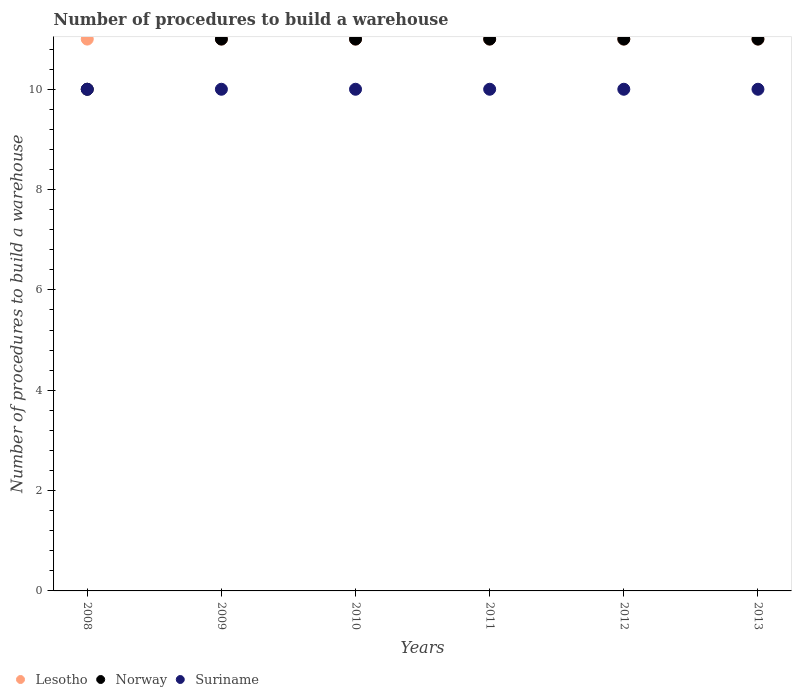How many different coloured dotlines are there?
Offer a terse response. 3. What is the number of procedures to build a warehouse in in Lesotho in 2008?
Keep it short and to the point. 11. Across all years, what is the maximum number of procedures to build a warehouse in in Norway?
Your answer should be compact. 11. Across all years, what is the minimum number of procedures to build a warehouse in in Lesotho?
Offer a very short reply. 11. In which year was the number of procedures to build a warehouse in in Suriname minimum?
Provide a short and direct response. 2008. What is the total number of procedures to build a warehouse in in Suriname in the graph?
Offer a very short reply. 60. What is the difference between the number of procedures to build a warehouse in in Lesotho in 2008 and that in 2009?
Offer a terse response. 0. What is the difference between the number of procedures to build a warehouse in in Suriname in 2011 and the number of procedures to build a warehouse in in Norway in 2008?
Your answer should be compact. 0. What is the average number of procedures to build a warehouse in in Lesotho per year?
Your answer should be compact. 11. In the year 2013, what is the difference between the number of procedures to build a warehouse in in Suriname and number of procedures to build a warehouse in in Norway?
Your answer should be compact. -1. In how many years, is the number of procedures to build a warehouse in in Norway greater than 5.6?
Your answer should be compact. 6. Is the difference between the number of procedures to build a warehouse in in Suriname in 2012 and 2013 greater than the difference between the number of procedures to build a warehouse in in Norway in 2012 and 2013?
Make the answer very short. No. What is the difference between the highest and the lowest number of procedures to build a warehouse in in Norway?
Your answer should be compact. 1. Is the number of procedures to build a warehouse in in Lesotho strictly greater than the number of procedures to build a warehouse in in Norway over the years?
Your response must be concise. No. Is the number of procedures to build a warehouse in in Lesotho strictly less than the number of procedures to build a warehouse in in Norway over the years?
Offer a terse response. No. How many years are there in the graph?
Your response must be concise. 6. What is the difference between two consecutive major ticks on the Y-axis?
Your answer should be very brief. 2. Does the graph contain any zero values?
Provide a short and direct response. No. Where does the legend appear in the graph?
Provide a succinct answer. Bottom left. How many legend labels are there?
Offer a terse response. 3. What is the title of the graph?
Provide a short and direct response. Number of procedures to build a warehouse. Does "Honduras" appear as one of the legend labels in the graph?
Offer a terse response. No. What is the label or title of the X-axis?
Keep it short and to the point. Years. What is the label or title of the Y-axis?
Ensure brevity in your answer.  Number of procedures to build a warehouse. What is the Number of procedures to build a warehouse of Lesotho in 2008?
Ensure brevity in your answer.  11. What is the Number of procedures to build a warehouse of Lesotho in 2009?
Make the answer very short. 11. What is the Number of procedures to build a warehouse in Norway in 2009?
Give a very brief answer. 11. What is the Number of procedures to build a warehouse of Lesotho in 2010?
Your answer should be very brief. 11. What is the Number of procedures to build a warehouse of Lesotho in 2011?
Offer a very short reply. 11. What is the Number of procedures to build a warehouse in Lesotho in 2012?
Offer a terse response. 11. What is the Number of procedures to build a warehouse in Suriname in 2012?
Keep it short and to the point. 10. What is the Number of procedures to build a warehouse of Norway in 2013?
Provide a succinct answer. 11. What is the total Number of procedures to build a warehouse of Norway in the graph?
Make the answer very short. 65. What is the difference between the Number of procedures to build a warehouse in Norway in 2008 and that in 2009?
Provide a succinct answer. -1. What is the difference between the Number of procedures to build a warehouse in Norway in 2008 and that in 2010?
Offer a very short reply. -1. What is the difference between the Number of procedures to build a warehouse of Suriname in 2008 and that in 2010?
Give a very brief answer. 0. What is the difference between the Number of procedures to build a warehouse in Norway in 2008 and that in 2011?
Your answer should be very brief. -1. What is the difference between the Number of procedures to build a warehouse of Lesotho in 2008 and that in 2012?
Ensure brevity in your answer.  0. What is the difference between the Number of procedures to build a warehouse in Norway in 2008 and that in 2012?
Make the answer very short. -1. What is the difference between the Number of procedures to build a warehouse of Suriname in 2008 and that in 2012?
Your answer should be very brief. 0. What is the difference between the Number of procedures to build a warehouse of Suriname in 2008 and that in 2013?
Provide a short and direct response. 0. What is the difference between the Number of procedures to build a warehouse in Lesotho in 2009 and that in 2010?
Your answer should be compact. 0. What is the difference between the Number of procedures to build a warehouse of Suriname in 2009 and that in 2010?
Keep it short and to the point. 0. What is the difference between the Number of procedures to build a warehouse in Norway in 2009 and that in 2011?
Your response must be concise. 0. What is the difference between the Number of procedures to build a warehouse in Suriname in 2009 and that in 2011?
Offer a terse response. 0. What is the difference between the Number of procedures to build a warehouse in Lesotho in 2009 and that in 2012?
Provide a succinct answer. 0. What is the difference between the Number of procedures to build a warehouse in Lesotho in 2009 and that in 2013?
Your answer should be compact. 0. What is the difference between the Number of procedures to build a warehouse in Norway in 2009 and that in 2013?
Offer a terse response. 0. What is the difference between the Number of procedures to build a warehouse of Suriname in 2009 and that in 2013?
Provide a succinct answer. 0. What is the difference between the Number of procedures to build a warehouse of Lesotho in 2010 and that in 2011?
Offer a very short reply. 0. What is the difference between the Number of procedures to build a warehouse of Norway in 2010 and that in 2011?
Your answer should be very brief. 0. What is the difference between the Number of procedures to build a warehouse in Suriname in 2010 and that in 2011?
Your answer should be compact. 0. What is the difference between the Number of procedures to build a warehouse of Lesotho in 2010 and that in 2012?
Offer a terse response. 0. What is the difference between the Number of procedures to build a warehouse of Suriname in 2010 and that in 2012?
Keep it short and to the point. 0. What is the difference between the Number of procedures to build a warehouse of Lesotho in 2010 and that in 2013?
Your answer should be compact. 0. What is the difference between the Number of procedures to build a warehouse of Lesotho in 2011 and that in 2012?
Ensure brevity in your answer.  0. What is the difference between the Number of procedures to build a warehouse in Suriname in 2011 and that in 2012?
Your response must be concise. 0. What is the difference between the Number of procedures to build a warehouse of Norway in 2011 and that in 2013?
Provide a succinct answer. 0. What is the difference between the Number of procedures to build a warehouse in Norway in 2012 and that in 2013?
Make the answer very short. 0. What is the difference between the Number of procedures to build a warehouse of Lesotho in 2008 and the Number of procedures to build a warehouse of Norway in 2009?
Offer a terse response. 0. What is the difference between the Number of procedures to build a warehouse in Lesotho in 2008 and the Number of procedures to build a warehouse in Suriname in 2010?
Your response must be concise. 1. What is the difference between the Number of procedures to build a warehouse of Lesotho in 2008 and the Number of procedures to build a warehouse of Norway in 2011?
Offer a terse response. 0. What is the difference between the Number of procedures to build a warehouse in Norway in 2008 and the Number of procedures to build a warehouse in Suriname in 2011?
Keep it short and to the point. 0. What is the difference between the Number of procedures to build a warehouse in Lesotho in 2008 and the Number of procedures to build a warehouse in Suriname in 2012?
Give a very brief answer. 1. What is the difference between the Number of procedures to build a warehouse in Lesotho in 2008 and the Number of procedures to build a warehouse in Norway in 2013?
Make the answer very short. 0. What is the difference between the Number of procedures to build a warehouse of Lesotho in 2008 and the Number of procedures to build a warehouse of Suriname in 2013?
Keep it short and to the point. 1. What is the difference between the Number of procedures to build a warehouse in Norway in 2008 and the Number of procedures to build a warehouse in Suriname in 2013?
Give a very brief answer. 0. What is the difference between the Number of procedures to build a warehouse in Lesotho in 2009 and the Number of procedures to build a warehouse in Suriname in 2010?
Offer a very short reply. 1. What is the difference between the Number of procedures to build a warehouse of Lesotho in 2009 and the Number of procedures to build a warehouse of Norway in 2011?
Offer a very short reply. 0. What is the difference between the Number of procedures to build a warehouse of Lesotho in 2009 and the Number of procedures to build a warehouse of Suriname in 2011?
Offer a very short reply. 1. What is the difference between the Number of procedures to build a warehouse of Norway in 2009 and the Number of procedures to build a warehouse of Suriname in 2011?
Provide a succinct answer. 1. What is the difference between the Number of procedures to build a warehouse in Lesotho in 2009 and the Number of procedures to build a warehouse in Norway in 2012?
Your answer should be compact. 0. What is the difference between the Number of procedures to build a warehouse of Norway in 2009 and the Number of procedures to build a warehouse of Suriname in 2012?
Provide a short and direct response. 1. What is the difference between the Number of procedures to build a warehouse in Norway in 2009 and the Number of procedures to build a warehouse in Suriname in 2013?
Give a very brief answer. 1. What is the difference between the Number of procedures to build a warehouse of Lesotho in 2010 and the Number of procedures to build a warehouse of Norway in 2011?
Make the answer very short. 0. What is the difference between the Number of procedures to build a warehouse in Lesotho in 2010 and the Number of procedures to build a warehouse in Suriname in 2011?
Your answer should be compact. 1. What is the difference between the Number of procedures to build a warehouse in Norway in 2010 and the Number of procedures to build a warehouse in Suriname in 2011?
Offer a terse response. 1. What is the difference between the Number of procedures to build a warehouse in Lesotho in 2010 and the Number of procedures to build a warehouse in Suriname in 2012?
Your answer should be very brief. 1. What is the difference between the Number of procedures to build a warehouse in Norway in 2010 and the Number of procedures to build a warehouse in Suriname in 2012?
Your answer should be compact. 1. What is the difference between the Number of procedures to build a warehouse in Lesotho in 2010 and the Number of procedures to build a warehouse in Norway in 2013?
Offer a very short reply. 0. What is the difference between the Number of procedures to build a warehouse in Lesotho in 2010 and the Number of procedures to build a warehouse in Suriname in 2013?
Ensure brevity in your answer.  1. What is the difference between the Number of procedures to build a warehouse of Lesotho in 2011 and the Number of procedures to build a warehouse of Norway in 2012?
Your response must be concise. 0. What is the difference between the Number of procedures to build a warehouse of Lesotho in 2011 and the Number of procedures to build a warehouse of Suriname in 2012?
Provide a short and direct response. 1. What is the difference between the Number of procedures to build a warehouse in Norway in 2011 and the Number of procedures to build a warehouse in Suriname in 2012?
Keep it short and to the point. 1. What is the difference between the Number of procedures to build a warehouse of Lesotho in 2011 and the Number of procedures to build a warehouse of Norway in 2013?
Keep it short and to the point. 0. What is the difference between the Number of procedures to build a warehouse in Lesotho in 2011 and the Number of procedures to build a warehouse in Suriname in 2013?
Your answer should be compact. 1. What is the difference between the Number of procedures to build a warehouse in Norway in 2011 and the Number of procedures to build a warehouse in Suriname in 2013?
Give a very brief answer. 1. What is the difference between the Number of procedures to build a warehouse in Lesotho in 2012 and the Number of procedures to build a warehouse in Norway in 2013?
Offer a very short reply. 0. What is the average Number of procedures to build a warehouse in Norway per year?
Ensure brevity in your answer.  10.83. What is the average Number of procedures to build a warehouse in Suriname per year?
Provide a short and direct response. 10. In the year 2008, what is the difference between the Number of procedures to build a warehouse of Lesotho and Number of procedures to build a warehouse of Suriname?
Your answer should be compact. 1. In the year 2009, what is the difference between the Number of procedures to build a warehouse of Lesotho and Number of procedures to build a warehouse of Suriname?
Make the answer very short. 1. In the year 2010, what is the difference between the Number of procedures to build a warehouse in Lesotho and Number of procedures to build a warehouse in Suriname?
Provide a succinct answer. 1. In the year 2011, what is the difference between the Number of procedures to build a warehouse of Lesotho and Number of procedures to build a warehouse of Norway?
Give a very brief answer. 0. In the year 2011, what is the difference between the Number of procedures to build a warehouse in Lesotho and Number of procedures to build a warehouse in Suriname?
Provide a short and direct response. 1. In the year 2011, what is the difference between the Number of procedures to build a warehouse in Norway and Number of procedures to build a warehouse in Suriname?
Your answer should be very brief. 1. In the year 2012, what is the difference between the Number of procedures to build a warehouse of Lesotho and Number of procedures to build a warehouse of Norway?
Make the answer very short. 0. In the year 2012, what is the difference between the Number of procedures to build a warehouse of Norway and Number of procedures to build a warehouse of Suriname?
Provide a short and direct response. 1. In the year 2013, what is the difference between the Number of procedures to build a warehouse of Lesotho and Number of procedures to build a warehouse of Norway?
Offer a very short reply. 0. In the year 2013, what is the difference between the Number of procedures to build a warehouse of Lesotho and Number of procedures to build a warehouse of Suriname?
Provide a succinct answer. 1. In the year 2013, what is the difference between the Number of procedures to build a warehouse of Norway and Number of procedures to build a warehouse of Suriname?
Offer a terse response. 1. What is the ratio of the Number of procedures to build a warehouse of Norway in 2008 to that in 2009?
Make the answer very short. 0.91. What is the ratio of the Number of procedures to build a warehouse in Lesotho in 2008 to that in 2011?
Give a very brief answer. 1. What is the ratio of the Number of procedures to build a warehouse of Norway in 2008 to that in 2011?
Provide a succinct answer. 0.91. What is the ratio of the Number of procedures to build a warehouse of Suriname in 2008 to that in 2011?
Your answer should be very brief. 1. What is the ratio of the Number of procedures to build a warehouse in Lesotho in 2008 to that in 2012?
Give a very brief answer. 1. What is the ratio of the Number of procedures to build a warehouse of Lesotho in 2008 to that in 2013?
Your answer should be very brief. 1. What is the ratio of the Number of procedures to build a warehouse in Suriname in 2008 to that in 2013?
Your answer should be compact. 1. What is the ratio of the Number of procedures to build a warehouse in Norway in 2009 to that in 2011?
Offer a terse response. 1. What is the ratio of the Number of procedures to build a warehouse in Lesotho in 2009 to that in 2012?
Offer a very short reply. 1. What is the ratio of the Number of procedures to build a warehouse in Suriname in 2009 to that in 2013?
Your answer should be compact. 1. What is the ratio of the Number of procedures to build a warehouse of Lesotho in 2010 to that in 2011?
Your answer should be compact. 1. What is the ratio of the Number of procedures to build a warehouse of Norway in 2010 to that in 2011?
Make the answer very short. 1. What is the ratio of the Number of procedures to build a warehouse in Suriname in 2010 to that in 2011?
Ensure brevity in your answer.  1. What is the ratio of the Number of procedures to build a warehouse of Norway in 2010 to that in 2012?
Offer a very short reply. 1. What is the ratio of the Number of procedures to build a warehouse of Norway in 2010 to that in 2013?
Make the answer very short. 1. What is the ratio of the Number of procedures to build a warehouse of Suriname in 2010 to that in 2013?
Ensure brevity in your answer.  1. What is the ratio of the Number of procedures to build a warehouse in Lesotho in 2011 to that in 2012?
Offer a terse response. 1. What is the ratio of the Number of procedures to build a warehouse in Norway in 2011 to that in 2012?
Give a very brief answer. 1. What is the ratio of the Number of procedures to build a warehouse in Norway in 2012 to that in 2013?
Ensure brevity in your answer.  1. What is the ratio of the Number of procedures to build a warehouse in Suriname in 2012 to that in 2013?
Offer a terse response. 1. What is the difference between the highest and the second highest Number of procedures to build a warehouse of Norway?
Your answer should be compact. 0. What is the difference between the highest and the second highest Number of procedures to build a warehouse in Suriname?
Ensure brevity in your answer.  0. What is the difference between the highest and the lowest Number of procedures to build a warehouse of Lesotho?
Make the answer very short. 0. 